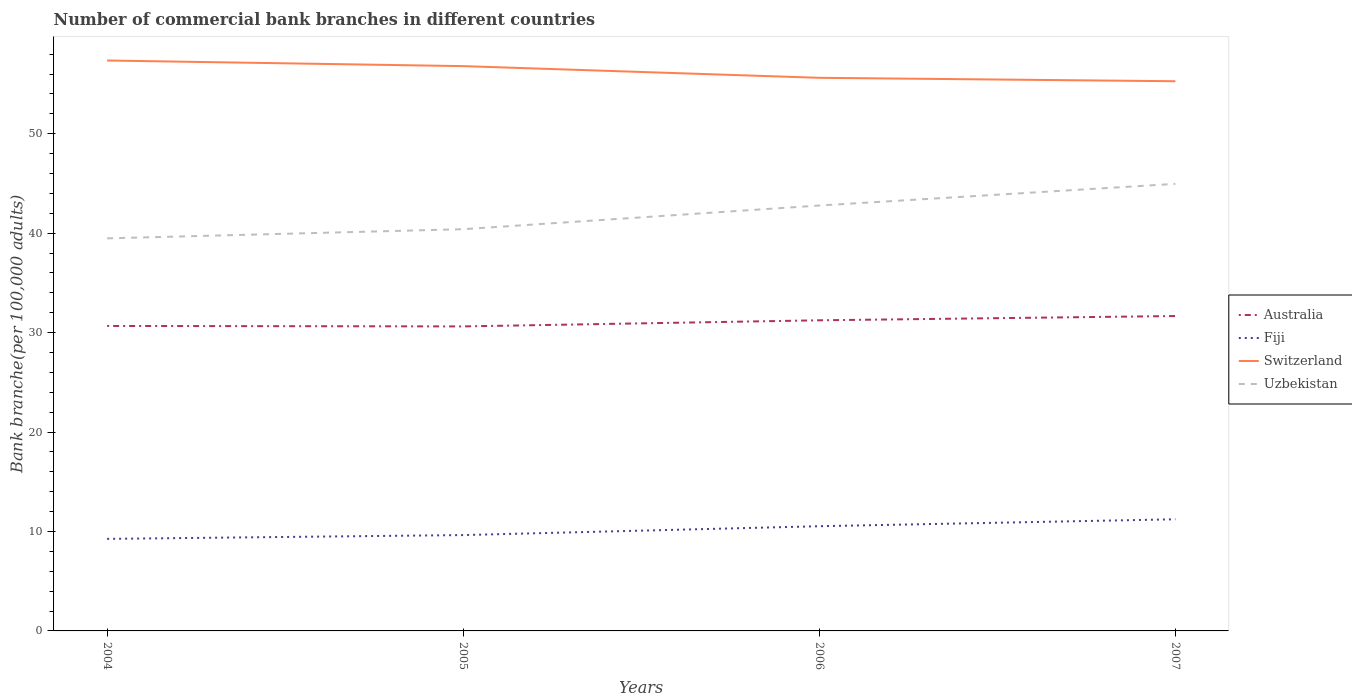Is the number of lines equal to the number of legend labels?
Offer a terse response. Yes. Across all years, what is the maximum number of commercial bank branches in Australia?
Your answer should be compact. 30.62. In which year was the number of commercial bank branches in Fiji maximum?
Your response must be concise. 2004. What is the total number of commercial bank branches in Fiji in the graph?
Offer a very short reply. -0.89. What is the difference between the highest and the second highest number of commercial bank branches in Australia?
Offer a terse response. 1.04. What is the difference between the highest and the lowest number of commercial bank branches in Australia?
Your answer should be very brief. 2. How many lines are there?
Offer a very short reply. 4. How many years are there in the graph?
Provide a succinct answer. 4. What is the difference between two consecutive major ticks on the Y-axis?
Provide a short and direct response. 10. Are the values on the major ticks of Y-axis written in scientific E-notation?
Provide a short and direct response. No. Does the graph contain any zero values?
Give a very brief answer. No. Does the graph contain grids?
Offer a terse response. No. How many legend labels are there?
Make the answer very short. 4. How are the legend labels stacked?
Your response must be concise. Vertical. What is the title of the graph?
Keep it short and to the point. Number of commercial bank branches in different countries. Does "European Union" appear as one of the legend labels in the graph?
Offer a very short reply. No. What is the label or title of the X-axis?
Provide a succinct answer. Years. What is the label or title of the Y-axis?
Provide a succinct answer. Bank branche(per 100,0 adults). What is the Bank branche(per 100,000 adults) in Australia in 2004?
Give a very brief answer. 30.66. What is the Bank branche(per 100,000 adults) in Fiji in 2004?
Provide a short and direct response. 9.26. What is the Bank branche(per 100,000 adults) in Switzerland in 2004?
Offer a very short reply. 57.36. What is the Bank branche(per 100,000 adults) in Uzbekistan in 2004?
Provide a short and direct response. 39.47. What is the Bank branche(per 100,000 adults) of Australia in 2005?
Offer a very short reply. 30.62. What is the Bank branche(per 100,000 adults) of Fiji in 2005?
Ensure brevity in your answer.  9.64. What is the Bank branche(per 100,000 adults) in Switzerland in 2005?
Make the answer very short. 56.79. What is the Bank branche(per 100,000 adults) in Uzbekistan in 2005?
Make the answer very short. 40.4. What is the Bank branche(per 100,000 adults) of Australia in 2006?
Ensure brevity in your answer.  31.23. What is the Bank branche(per 100,000 adults) of Fiji in 2006?
Give a very brief answer. 10.53. What is the Bank branche(per 100,000 adults) of Switzerland in 2006?
Provide a succinct answer. 55.62. What is the Bank branche(per 100,000 adults) of Uzbekistan in 2006?
Your response must be concise. 42.78. What is the Bank branche(per 100,000 adults) in Australia in 2007?
Offer a very short reply. 31.66. What is the Bank branche(per 100,000 adults) in Fiji in 2007?
Keep it short and to the point. 11.23. What is the Bank branche(per 100,000 adults) in Switzerland in 2007?
Your response must be concise. 55.27. What is the Bank branche(per 100,000 adults) of Uzbekistan in 2007?
Offer a very short reply. 44.95. Across all years, what is the maximum Bank branche(per 100,000 adults) of Australia?
Offer a terse response. 31.66. Across all years, what is the maximum Bank branche(per 100,000 adults) of Fiji?
Your answer should be compact. 11.23. Across all years, what is the maximum Bank branche(per 100,000 adults) of Switzerland?
Provide a short and direct response. 57.36. Across all years, what is the maximum Bank branche(per 100,000 adults) in Uzbekistan?
Ensure brevity in your answer.  44.95. Across all years, what is the minimum Bank branche(per 100,000 adults) of Australia?
Ensure brevity in your answer.  30.62. Across all years, what is the minimum Bank branche(per 100,000 adults) of Fiji?
Your answer should be compact. 9.26. Across all years, what is the minimum Bank branche(per 100,000 adults) in Switzerland?
Offer a very short reply. 55.27. Across all years, what is the minimum Bank branche(per 100,000 adults) of Uzbekistan?
Give a very brief answer. 39.47. What is the total Bank branche(per 100,000 adults) in Australia in the graph?
Provide a short and direct response. 124.18. What is the total Bank branche(per 100,000 adults) of Fiji in the graph?
Provide a short and direct response. 40.65. What is the total Bank branche(per 100,000 adults) in Switzerland in the graph?
Ensure brevity in your answer.  225.04. What is the total Bank branche(per 100,000 adults) of Uzbekistan in the graph?
Make the answer very short. 167.6. What is the difference between the Bank branche(per 100,000 adults) in Australia in 2004 and that in 2005?
Make the answer very short. 0.05. What is the difference between the Bank branche(per 100,000 adults) in Fiji in 2004 and that in 2005?
Make the answer very short. -0.38. What is the difference between the Bank branche(per 100,000 adults) in Switzerland in 2004 and that in 2005?
Make the answer very short. 0.57. What is the difference between the Bank branche(per 100,000 adults) in Uzbekistan in 2004 and that in 2005?
Your answer should be very brief. -0.92. What is the difference between the Bank branche(per 100,000 adults) in Australia in 2004 and that in 2006?
Provide a short and direct response. -0.57. What is the difference between the Bank branche(per 100,000 adults) in Fiji in 2004 and that in 2006?
Keep it short and to the point. -1.27. What is the difference between the Bank branche(per 100,000 adults) in Switzerland in 2004 and that in 2006?
Provide a succinct answer. 1.74. What is the difference between the Bank branche(per 100,000 adults) in Uzbekistan in 2004 and that in 2006?
Provide a short and direct response. -3.3. What is the difference between the Bank branche(per 100,000 adults) of Australia in 2004 and that in 2007?
Your response must be concise. -1. What is the difference between the Bank branche(per 100,000 adults) in Fiji in 2004 and that in 2007?
Your answer should be compact. -1.97. What is the difference between the Bank branche(per 100,000 adults) in Switzerland in 2004 and that in 2007?
Offer a very short reply. 2.09. What is the difference between the Bank branche(per 100,000 adults) in Uzbekistan in 2004 and that in 2007?
Offer a very short reply. -5.48. What is the difference between the Bank branche(per 100,000 adults) in Australia in 2005 and that in 2006?
Provide a succinct answer. -0.61. What is the difference between the Bank branche(per 100,000 adults) in Fiji in 2005 and that in 2006?
Keep it short and to the point. -0.89. What is the difference between the Bank branche(per 100,000 adults) of Switzerland in 2005 and that in 2006?
Provide a succinct answer. 1.18. What is the difference between the Bank branche(per 100,000 adults) in Uzbekistan in 2005 and that in 2006?
Your answer should be very brief. -2.38. What is the difference between the Bank branche(per 100,000 adults) of Australia in 2005 and that in 2007?
Your response must be concise. -1.04. What is the difference between the Bank branche(per 100,000 adults) of Fiji in 2005 and that in 2007?
Your answer should be very brief. -1.59. What is the difference between the Bank branche(per 100,000 adults) in Switzerland in 2005 and that in 2007?
Make the answer very short. 1.52. What is the difference between the Bank branche(per 100,000 adults) in Uzbekistan in 2005 and that in 2007?
Your response must be concise. -4.56. What is the difference between the Bank branche(per 100,000 adults) of Australia in 2006 and that in 2007?
Offer a very short reply. -0.43. What is the difference between the Bank branche(per 100,000 adults) of Fiji in 2006 and that in 2007?
Your response must be concise. -0.7. What is the difference between the Bank branche(per 100,000 adults) in Switzerland in 2006 and that in 2007?
Offer a very short reply. 0.34. What is the difference between the Bank branche(per 100,000 adults) in Uzbekistan in 2006 and that in 2007?
Offer a terse response. -2.18. What is the difference between the Bank branche(per 100,000 adults) in Australia in 2004 and the Bank branche(per 100,000 adults) in Fiji in 2005?
Keep it short and to the point. 21.03. What is the difference between the Bank branche(per 100,000 adults) in Australia in 2004 and the Bank branche(per 100,000 adults) in Switzerland in 2005?
Your response must be concise. -26.13. What is the difference between the Bank branche(per 100,000 adults) of Australia in 2004 and the Bank branche(per 100,000 adults) of Uzbekistan in 2005?
Ensure brevity in your answer.  -9.73. What is the difference between the Bank branche(per 100,000 adults) in Fiji in 2004 and the Bank branche(per 100,000 adults) in Switzerland in 2005?
Your answer should be compact. -47.54. What is the difference between the Bank branche(per 100,000 adults) in Fiji in 2004 and the Bank branche(per 100,000 adults) in Uzbekistan in 2005?
Your answer should be very brief. -31.14. What is the difference between the Bank branche(per 100,000 adults) in Switzerland in 2004 and the Bank branche(per 100,000 adults) in Uzbekistan in 2005?
Ensure brevity in your answer.  16.96. What is the difference between the Bank branche(per 100,000 adults) of Australia in 2004 and the Bank branche(per 100,000 adults) of Fiji in 2006?
Provide a short and direct response. 20.14. What is the difference between the Bank branche(per 100,000 adults) in Australia in 2004 and the Bank branche(per 100,000 adults) in Switzerland in 2006?
Provide a short and direct response. -24.95. What is the difference between the Bank branche(per 100,000 adults) of Australia in 2004 and the Bank branche(per 100,000 adults) of Uzbekistan in 2006?
Your response must be concise. -12.11. What is the difference between the Bank branche(per 100,000 adults) in Fiji in 2004 and the Bank branche(per 100,000 adults) in Switzerland in 2006?
Keep it short and to the point. -46.36. What is the difference between the Bank branche(per 100,000 adults) in Fiji in 2004 and the Bank branche(per 100,000 adults) in Uzbekistan in 2006?
Keep it short and to the point. -33.52. What is the difference between the Bank branche(per 100,000 adults) of Switzerland in 2004 and the Bank branche(per 100,000 adults) of Uzbekistan in 2006?
Your answer should be compact. 14.58. What is the difference between the Bank branche(per 100,000 adults) of Australia in 2004 and the Bank branche(per 100,000 adults) of Fiji in 2007?
Give a very brief answer. 19.44. What is the difference between the Bank branche(per 100,000 adults) of Australia in 2004 and the Bank branche(per 100,000 adults) of Switzerland in 2007?
Give a very brief answer. -24.61. What is the difference between the Bank branche(per 100,000 adults) of Australia in 2004 and the Bank branche(per 100,000 adults) of Uzbekistan in 2007?
Provide a succinct answer. -14.29. What is the difference between the Bank branche(per 100,000 adults) in Fiji in 2004 and the Bank branche(per 100,000 adults) in Switzerland in 2007?
Offer a terse response. -46.02. What is the difference between the Bank branche(per 100,000 adults) of Fiji in 2004 and the Bank branche(per 100,000 adults) of Uzbekistan in 2007?
Your answer should be very brief. -35.7. What is the difference between the Bank branche(per 100,000 adults) in Switzerland in 2004 and the Bank branche(per 100,000 adults) in Uzbekistan in 2007?
Provide a short and direct response. 12.4. What is the difference between the Bank branche(per 100,000 adults) in Australia in 2005 and the Bank branche(per 100,000 adults) in Fiji in 2006?
Provide a short and direct response. 20.09. What is the difference between the Bank branche(per 100,000 adults) in Australia in 2005 and the Bank branche(per 100,000 adults) in Switzerland in 2006?
Your answer should be very brief. -25. What is the difference between the Bank branche(per 100,000 adults) of Australia in 2005 and the Bank branche(per 100,000 adults) of Uzbekistan in 2006?
Offer a very short reply. -12.16. What is the difference between the Bank branche(per 100,000 adults) in Fiji in 2005 and the Bank branche(per 100,000 adults) in Switzerland in 2006?
Provide a succinct answer. -45.98. What is the difference between the Bank branche(per 100,000 adults) of Fiji in 2005 and the Bank branche(per 100,000 adults) of Uzbekistan in 2006?
Make the answer very short. -33.14. What is the difference between the Bank branche(per 100,000 adults) of Switzerland in 2005 and the Bank branche(per 100,000 adults) of Uzbekistan in 2006?
Provide a short and direct response. 14.02. What is the difference between the Bank branche(per 100,000 adults) of Australia in 2005 and the Bank branche(per 100,000 adults) of Fiji in 2007?
Offer a very short reply. 19.39. What is the difference between the Bank branche(per 100,000 adults) of Australia in 2005 and the Bank branche(per 100,000 adults) of Switzerland in 2007?
Your answer should be compact. -24.65. What is the difference between the Bank branche(per 100,000 adults) of Australia in 2005 and the Bank branche(per 100,000 adults) of Uzbekistan in 2007?
Ensure brevity in your answer.  -14.33. What is the difference between the Bank branche(per 100,000 adults) in Fiji in 2005 and the Bank branche(per 100,000 adults) in Switzerland in 2007?
Keep it short and to the point. -45.63. What is the difference between the Bank branche(per 100,000 adults) of Fiji in 2005 and the Bank branche(per 100,000 adults) of Uzbekistan in 2007?
Offer a terse response. -35.32. What is the difference between the Bank branche(per 100,000 adults) in Switzerland in 2005 and the Bank branche(per 100,000 adults) in Uzbekistan in 2007?
Provide a succinct answer. 11.84. What is the difference between the Bank branche(per 100,000 adults) of Australia in 2006 and the Bank branche(per 100,000 adults) of Fiji in 2007?
Ensure brevity in your answer.  20.01. What is the difference between the Bank branche(per 100,000 adults) of Australia in 2006 and the Bank branche(per 100,000 adults) of Switzerland in 2007?
Offer a very short reply. -24.04. What is the difference between the Bank branche(per 100,000 adults) in Australia in 2006 and the Bank branche(per 100,000 adults) in Uzbekistan in 2007?
Provide a short and direct response. -13.72. What is the difference between the Bank branche(per 100,000 adults) of Fiji in 2006 and the Bank branche(per 100,000 adults) of Switzerland in 2007?
Offer a very short reply. -44.74. What is the difference between the Bank branche(per 100,000 adults) in Fiji in 2006 and the Bank branche(per 100,000 adults) in Uzbekistan in 2007?
Keep it short and to the point. -34.42. What is the difference between the Bank branche(per 100,000 adults) in Switzerland in 2006 and the Bank branche(per 100,000 adults) in Uzbekistan in 2007?
Your answer should be very brief. 10.66. What is the average Bank branche(per 100,000 adults) in Australia per year?
Give a very brief answer. 31.05. What is the average Bank branche(per 100,000 adults) of Fiji per year?
Offer a terse response. 10.16. What is the average Bank branche(per 100,000 adults) in Switzerland per year?
Give a very brief answer. 56.26. What is the average Bank branche(per 100,000 adults) of Uzbekistan per year?
Ensure brevity in your answer.  41.9. In the year 2004, what is the difference between the Bank branche(per 100,000 adults) in Australia and Bank branche(per 100,000 adults) in Fiji?
Make the answer very short. 21.41. In the year 2004, what is the difference between the Bank branche(per 100,000 adults) in Australia and Bank branche(per 100,000 adults) in Switzerland?
Give a very brief answer. -26.69. In the year 2004, what is the difference between the Bank branche(per 100,000 adults) of Australia and Bank branche(per 100,000 adults) of Uzbekistan?
Your answer should be compact. -8.81. In the year 2004, what is the difference between the Bank branche(per 100,000 adults) of Fiji and Bank branche(per 100,000 adults) of Switzerland?
Your response must be concise. -48.1. In the year 2004, what is the difference between the Bank branche(per 100,000 adults) of Fiji and Bank branche(per 100,000 adults) of Uzbekistan?
Provide a short and direct response. -30.22. In the year 2004, what is the difference between the Bank branche(per 100,000 adults) in Switzerland and Bank branche(per 100,000 adults) in Uzbekistan?
Provide a succinct answer. 17.89. In the year 2005, what is the difference between the Bank branche(per 100,000 adults) in Australia and Bank branche(per 100,000 adults) in Fiji?
Offer a very short reply. 20.98. In the year 2005, what is the difference between the Bank branche(per 100,000 adults) in Australia and Bank branche(per 100,000 adults) in Switzerland?
Your response must be concise. -26.17. In the year 2005, what is the difference between the Bank branche(per 100,000 adults) of Australia and Bank branche(per 100,000 adults) of Uzbekistan?
Your response must be concise. -9.78. In the year 2005, what is the difference between the Bank branche(per 100,000 adults) of Fiji and Bank branche(per 100,000 adults) of Switzerland?
Your answer should be compact. -47.15. In the year 2005, what is the difference between the Bank branche(per 100,000 adults) in Fiji and Bank branche(per 100,000 adults) in Uzbekistan?
Keep it short and to the point. -30.76. In the year 2005, what is the difference between the Bank branche(per 100,000 adults) in Switzerland and Bank branche(per 100,000 adults) in Uzbekistan?
Give a very brief answer. 16.4. In the year 2006, what is the difference between the Bank branche(per 100,000 adults) of Australia and Bank branche(per 100,000 adults) of Fiji?
Ensure brevity in your answer.  20.71. In the year 2006, what is the difference between the Bank branche(per 100,000 adults) in Australia and Bank branche(per 100,000 adults) in Switzerland?
Ensure brevity in your answer.  -24.38. In the year 2006, what is the difference between the Bank branche(per 100,000 adults) of Australia and Bank branche(per 100,000 adults) of Uzbekistan?
Provide a short and direct response. -11.54. In the year 2006, what is the difference between the Bank branche(per 100,000 adults) of Fiji and Bank branche(per 100,000 adults) of Switzerland?
Offer a terse response. -45.09. In the year 2006, what is the difference between the Bank branche(per 100,000 adults) of Fiji and Bank branche(per 100,000 adults) of Uzbekistan?
Your answer should be very brief. -32.25. In the year 2006, what is the difference between the Bank branche(per 100,000 adults) in Switzerland and Bank branche(per 100,000 adults) in Uzbekistan?
Your answer should be very brief. 12.84. In the year 2007, what is the difference between the Bank branche(per 100,000 adults) in Australia and Bank branche(per 100,000 adults) in Fiji?
Your response must be concise. 20.44. In the year 2007, what is the difference between the Bank branche(per 100,000 adults) of Australia and Bank branche(per 100,000 adults) of Switzerland?
Provide a succinct answer. -23.61. In the year 2007, what is the difference between the Bank branche(per 100,000 adults) in Australia and Bank branche(per 100,000 adults) in Uzbekistan?
Your response must be concise. -13.29. In the year 2007, what is the difference between the Bank branche(per 100,000 adults) of Fiji and Bank branche(per 100,000 adults) of Switzerland?
Make the answer very short. -44.05. In the year 2007, what is the difference between the Bank branche(per 100,000 adults) in Fiji and Bank branche(per 100,000 adults) in Uzbekistan?
Provide a short and direct response. -33.73. In the year 2007, what is the difference between the Bank branche(per 100,000 adults) of Switzerland and Bank branche(per 100,000 adults) of Uzbekistan?
Ensure brevity in your answer.  10.32. What is the ratio of the Bank branche(per 100,000 adults) in Australia in 2004 to that in 2005?
Keep it short and to the point. 1. What is the ratio of the Bank branche(per 100,000 adults) in Fiji in 2004 to that in 2005?
Offer a terse response. 0.96. What is the ratio of the Bank branche(per 100,000 adults) of Uzbekistan in 2004 to that in 2005?
Ensure brevity in your answer.  0.98. What is the ratio of the Bank branche(per 100,000 adults) in Australia in 2004 to that in 2006?
Ensure brevity in your answer.  0.98. What is the ratio of the Bank branche(per 100,000 adults) in Fiji in 2004 to that in 2006?
Your answer should be compact. 0.88. What is the ratio of the Bank branche(per 100,000 adults) of Switzerland in 2004 to that in 2006?
Your response must be concise. 1.03. What is the ratio of the Bank branche(per 100,000 adults) of Uzbekistan in 2004 to that in 2006?
Give a very brief answer. 0.92. What is the ratio of the Bank branche(per 100,000 adults) in Australia in 2004 to that in 2007?
Offer a terse response. 0.97. What is the ratio of the Bank branche(per 100,000 adults) in Fiji in 2004 to that in 2007?
Give a very brief answer. 0.82. What is the ratio of the Bank branche(per 100,000 adults) in Switzerland in 2004 to that in 2007?
Your answer should be compact. 1.04. What is the ratio of the Bank branche(per 100,000 adults) in Uzbekistan in 2004 to that in 2007?
Ensure brevity in your answer.  0.88. What is the ratio of the Bank branche(per 100,000 adults) in Australia in 2005 to that in 2006?
Provide a short and direct response. 0.98. What is the ratio of the Bank branche(per 100,000 adults) in Fiji in 2005 to that in 2006?
Ensure brevity in your answer.  0.92. What is the ratio of the Bank branche(per 100,000 adults) of Switzerland in 2005 to that in 2006?
Your response must be concise. 1.02. What is the ratio of the Bank branche(per 100,000 adults) of Uzbekistan in 2005 to that in 2006?
Give a very brief answer. 0.94. What is the ratio of the Bank branche(per 100,000 adults) of Australia in 2005 to that in 2007?
Offer a very short reply. 0.97. What is the ratio of the Bank branche(per 100,000 adults) of Fiji in 2005 to that in 2007?
Provide a short and direct response. 0.86. What is the ratio of the Bank branche(per 100,000 adults) of Switzerland in 2005 to that in 2007?
Your answer should be very brief. 1.03. What is the ratio of the Bank branche(per 100,000 adults) of Uzbekistan in 2005 to that in 2007?
Offer a terse response. 0.9. What is the ratio of the Bank branche(per 100,000 adults) in Australia in 2006 to that in 2007?
Ensure brevity in your answer.  0.99. What is the ratio of the Bank branche(per 100,000 adults) in Fiji in 2006 to that in 2007?
Your answer should be compact. 0.94. What is the ratio of the Bank branche(per 100,000 adults) in Uzbekistan in 2006 to that in 2007?
Provide a short and direct response. 0.95. What is the difference between the highest and the second highest Bank branche(per 100,000 adults) of Australia?
Make the answer very short. 0.43. What is the difference between the highest and the second highest Bank branche(per 100,000 adults) in Fiji?
Offer a very short reply. 0.7. What is the difference between the highest and the second highest Bank branche(per 100,000 adults) of Switzerland?
Provide a short and direct response. 0.57. What is the difference between the highest and the second highest Bank branche(per 100,000 adults) in Uzbekistan?
Your answer should be compact. 2.18. What is the difference between the highest and the lowest Bank branche(per 100,000 adults) in Australia?
Offer a very short reply. 1.04. What is the difference between the highest and the lowest Bank branche(per 100,000 adults) in Fiji?
Your response must be concise. 1.97. What is the difference between the highest and the lowest Bank branche(per 100,000 adults) of Switzerland?
Keep it short and to the point. 2.09. What is the difference between the highest and the lowest Bank branche(per 100,000 adults) in Uzbekistan?
Your answer should be very brief. 5.48. 